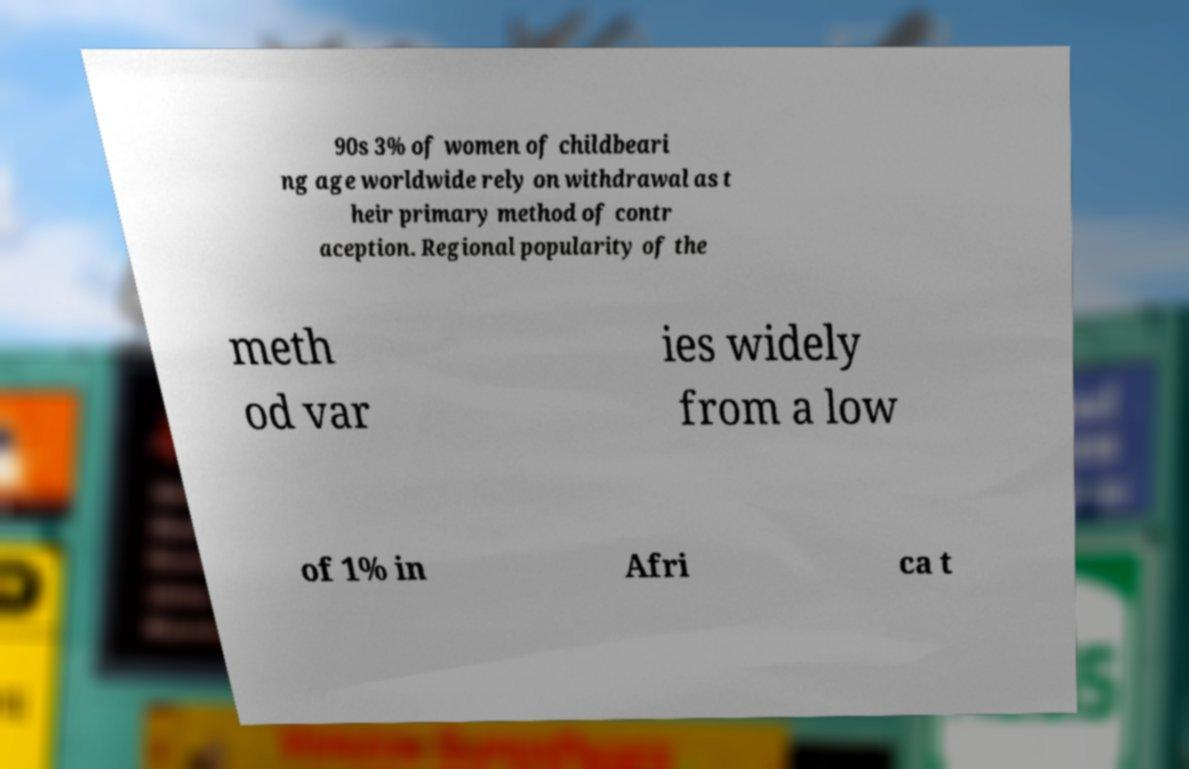Please read and relay the text visible in this image. What does it say? 90s 3% of women of childbeari ng age worldwide rely on withdrawal as t heir primary method of contr aception. Regional popularity of the meth od var ies widely from a low of 1% in Afri ca t 